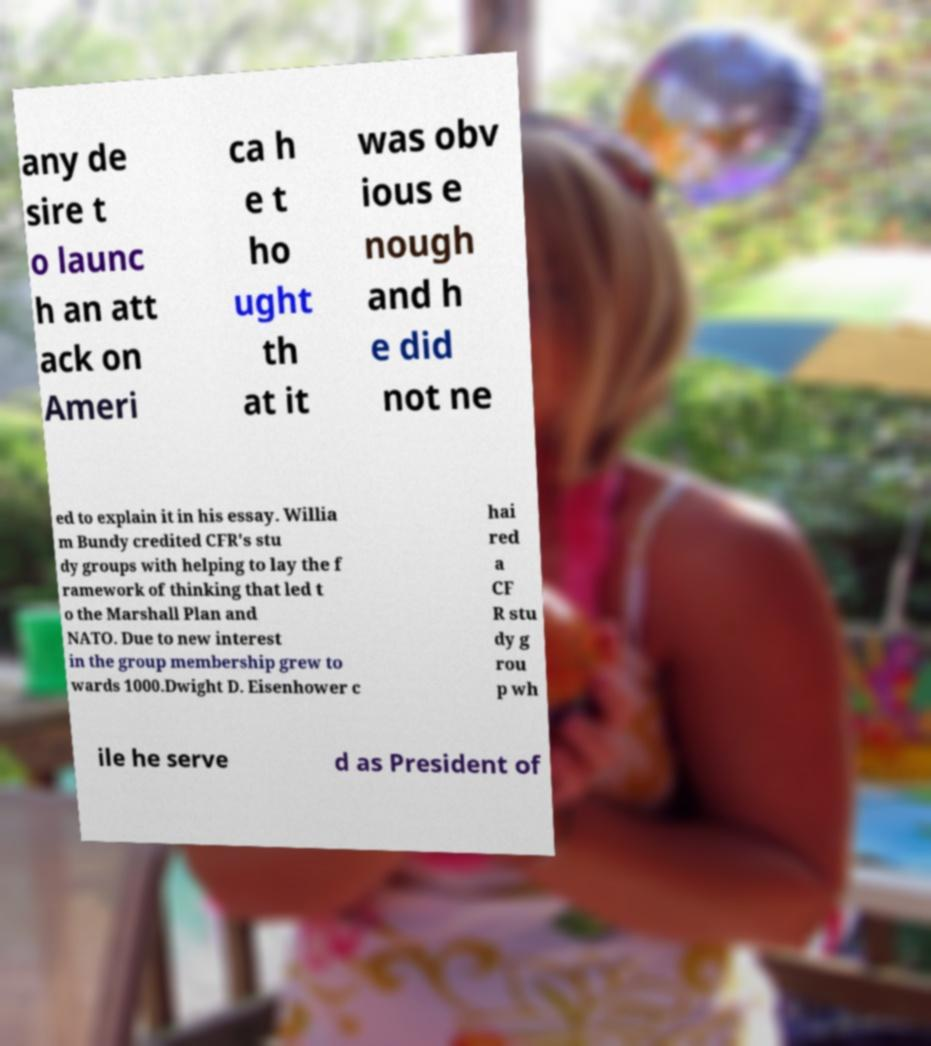For documentation purposes, I need the text within this image transcribed. Could you provide that? any de sire t o launc h an att ack on Ameri ca h e t ho ught th at it was obv ious e nough and h e did not ne ed to explain it in his essay. Willia m Bundy credited CFR's stu dy groups with helping to lay the f ramework of thinking that led t o the Marshall Plan and NATO. Due to new interest in the group membership grew to wards 1000.Dwight D. Eisenhower c hai red a CF R stu dy g rou p wh ile he serve d as President of 